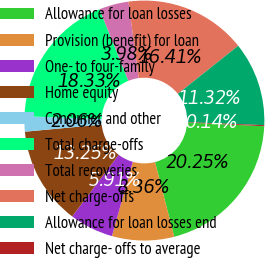<chart> <loc_0><loc_0><loc_500><loc_500><pie_chart><fcel>Allowance for loan losses<fcel>Provision (benefit) for loan<fcel>One- to four-family<fcel>Home equity<fcel>Consumer and other<fcel>Total charge-offs<fcel>Total recoveries<fcel>Net charge-offs<fcel>Allowance for loan losses end<fcel>Net charge- offs to average<nl><fcel>20.25%<fcel>8.36%<fcel>5.91%<fcel>13.25%<fcel>2.06%<fcel>18.33%<fcel>3.98%<fcel>16.41%<fcel>11.32%<fcel>0.14%<nl></chart> 